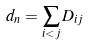Convert formula to latex. <formula><loc_0><loc_0><loc_500><loc_500>d _ { n } = \sum _ { i < j } D _ { i j }</formula> 